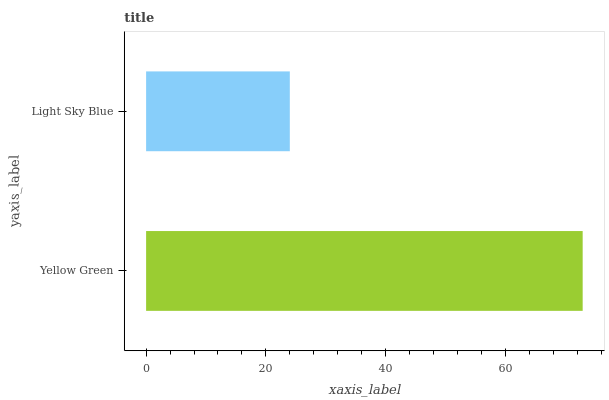Is Light Sky Blue the minimum?
Answer yes or no. Yes. Is Yellow Green the maximum?
Answer yes or no. Yes. Is Light Sky Blue the maximum?
Answer yes or no. No. Is Yellow Green greater than Light Sky Blue?
Answer yes or no. Yes. Is Light Sky Blue less than Yellow Green?
Answer yes or no. Yes. Is Light Sky Blue greater than Yellow Green?
Answer yes or no. No. Is Yellow Green less than Light Sky Blue?
Answer yes or no. No. Is Yellow Green the high median?
Answer yes or no. Yes. Is Light Sky Blue the low median?
Answer yes or no. Yes. Is Light Sky Blue the high median?
Answer yes or no. No. Is Yellow Green the low median?
Answer yes or no. No. 